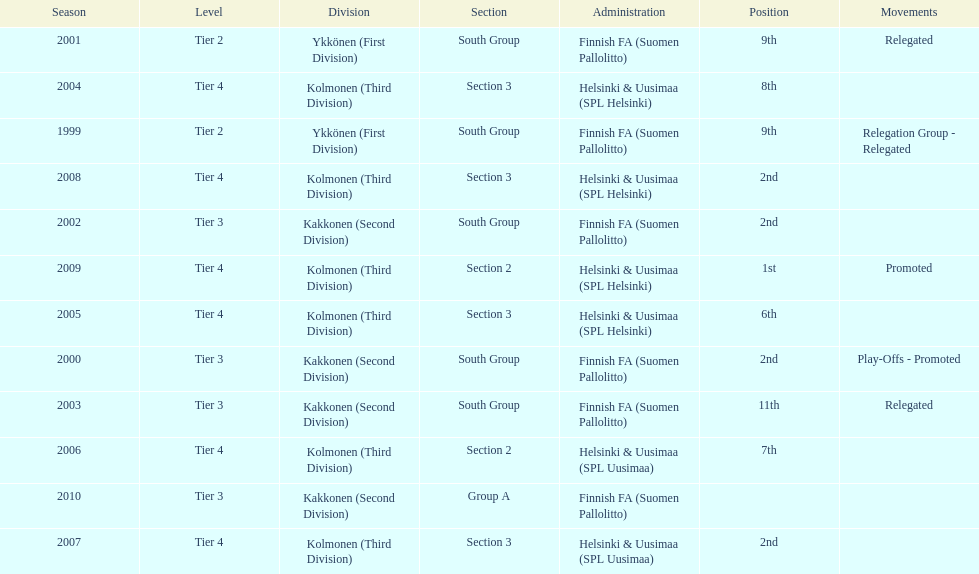What position did this team get after getting 9th place in 1999? 2nd. 